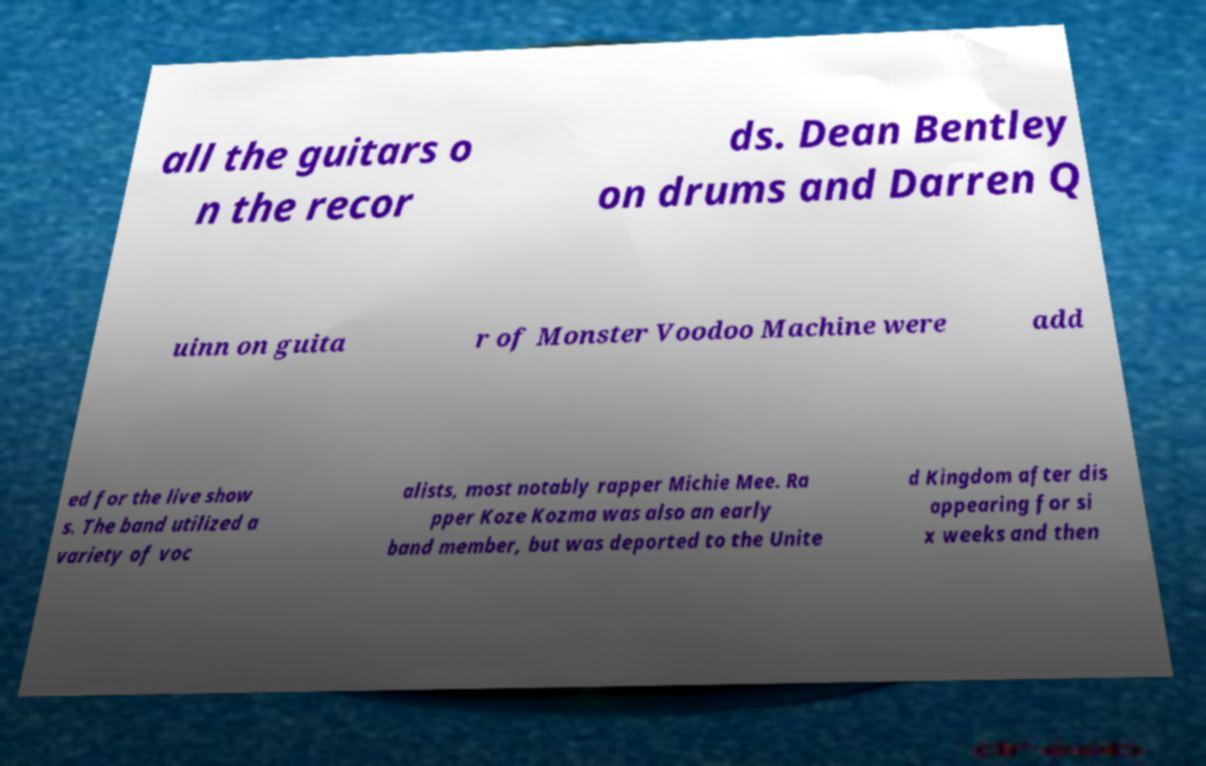I need the written content from this picture converted into text. Can you do that? all the guitars o n the recor ds. Dean Bentley on drums and Darren Q uinn on guita r of Monster Voodoo Machine were add ed for the live show s. The band utilized a variety of voc alists, most notably rapper Michie Mee. Ra pper Koze Kozma was also an early band member, but was deported to the Unite d Kingdom after dis appearing for si x weeks and then 